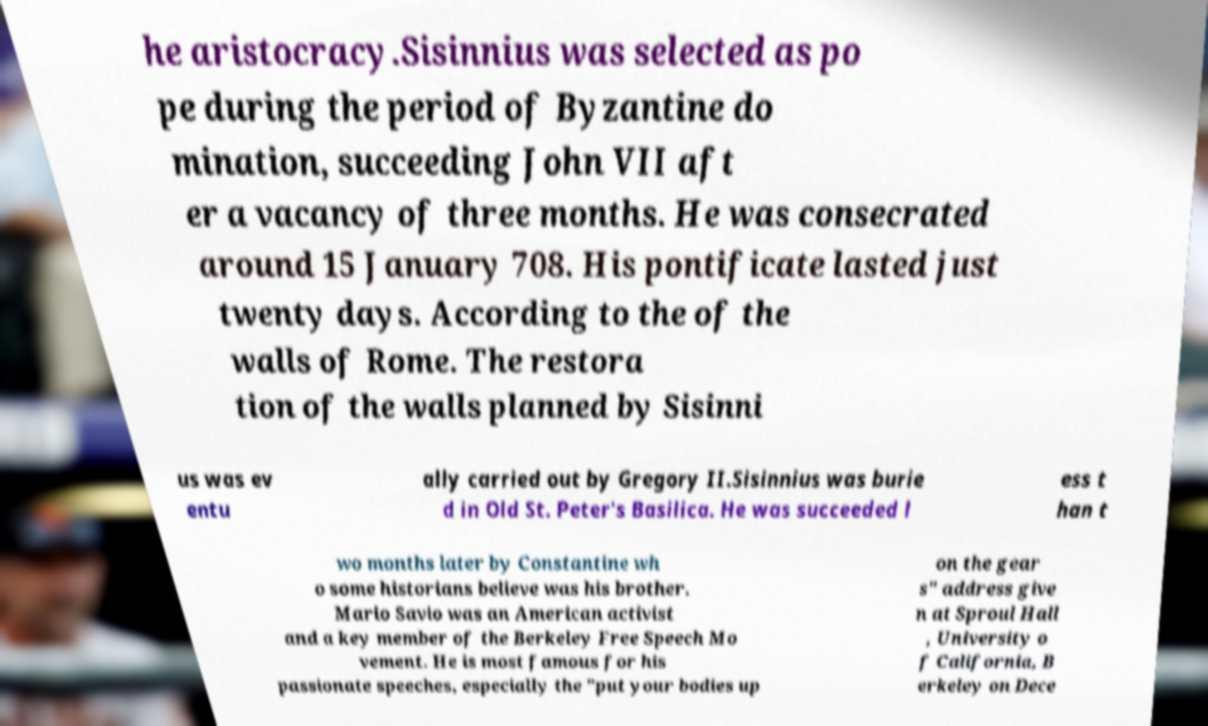Please identify and transcribe the text found in this image. he aristocracy.Sisinnius was selected as po pe during the period of Byzantine do mination, succeeding John VII aft er a vacancy of three months. He was consecrated around 15 January 708. His pontificate lasted just twenty days. According to the of the walls of Rome. The restora tion of the walls planned by Sisinni us was ev entu ally carried out by Gregory II.Sisinnius was burie d in Old St. Peter's Basilica. He was succeeded l ess t han t wo months later by Constantine wh o some historians believe was his brother. Mario Savio was an American activist and a key member of the Berkeley Free Speech Mo vement. He is most famous for his passionate speeches, especially the "put your bodies up on the gear s" address give n at Sproul Hall , University o f California, B erkeley on Dece 